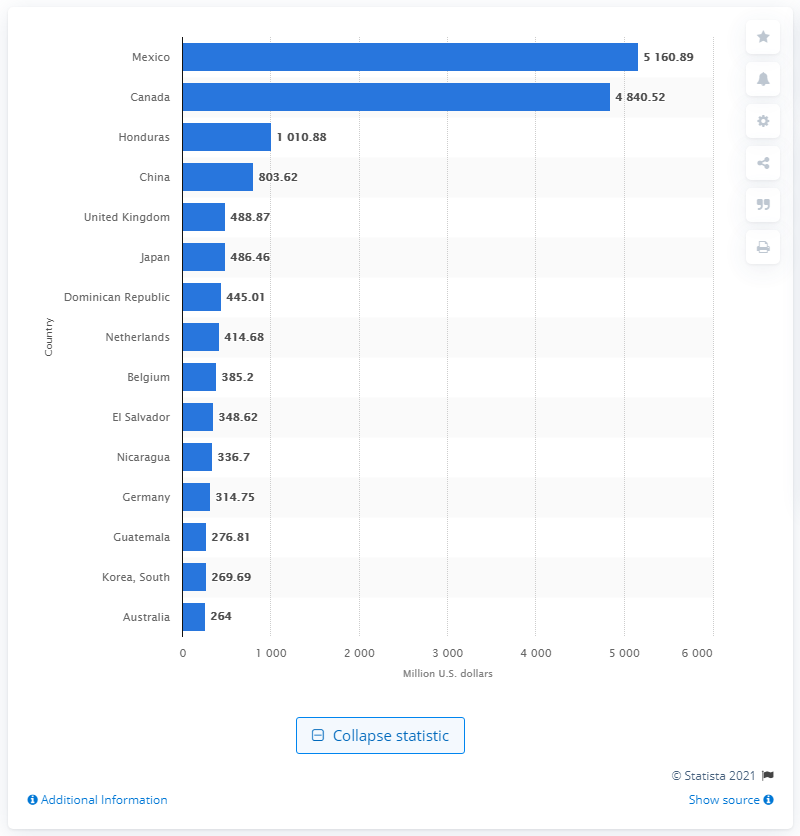Indicate a few pertinent items in this graphic. In 2020, Canada was the second leading market for U.S. textile and apparel exports, accounting for a significant portion of the total value of these exports. In 2020, the value of Canada's exports in U.S. dollars was approximately 48,405.20. 